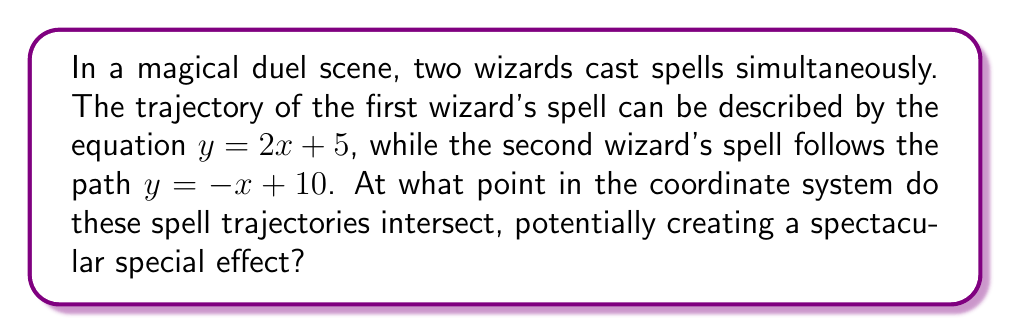Could you help me with this problem? Let's solve this step-by-step:

1) We have two linear equations representing the spell trajectories:
   Spell 1: $y = 2x + 5$
   Spell 2: $y = -x + 10$

2) To find the intersection point, we need to solve these equations simultaneously. At the intersection point, the $x$ and $y$ coordinates will be the same for both equations.

3) We can set the right sides of the equations equal to each other:
   $2x + 5 = -x + 10$

4) Now, let's solve for $x$:
   $2x + 5 = -x + 10$
   $3x = 5$
   $x = \frac{5}{3}$

5) Now that we know the $x$-coordinate, we can substitute this value into either of the original equations to find the $y$-coordinate. Let's use the first equation:

   $y = 2(\frac{5}{3}) + 5$
   $y = \frac{10}{3} + 5$
   $y = \frac{10}{3} + \frac{15}{3}$
   $y = \frac{25}{3}$

6) Therefore, the intersection point is $(\frac{5}{3}, \frac{25}{3})$.

[asy]
import geometry;

size(200);
defaultpen(fontsize(10pt));

xaxis("x", arrow=Arrow);
yaxis("y", arrow=Arrow);

real x1 = -1, x2 = 4;
real y1 = 2*x1 + 5, y2 = 2*x2 + 5;
draw((x1,y1)--(x2,y2), blue, arrow=Arrow);

real y3 = -x1 + 10, y4 = -x2 + 10;
draw((x1,y3)--(x2,y4), red, arrow=Arrow);

dot((5/3, 25/3), p=black);
label("(5/3, 25/3)", (5/3, 25/3), NE);

label("Spell 1", (3,11), blue);
label("Spell 2", (3,7), red);
[/asy]
Answer: $(\frac{5}{3}, \frac{25}{3})$ 